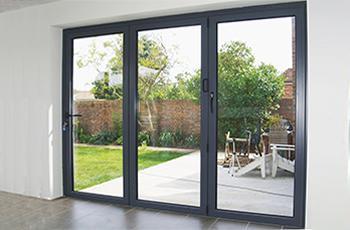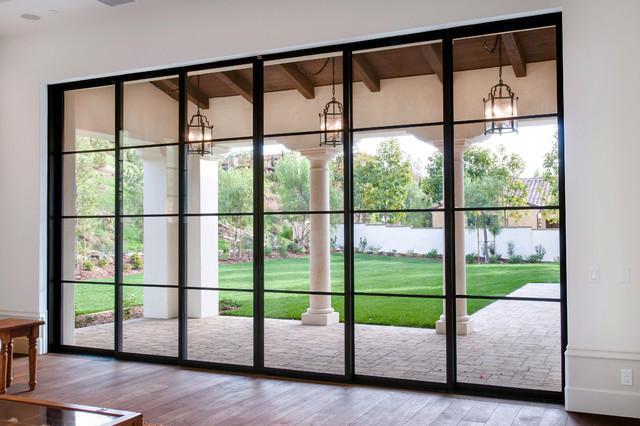The first image is the image on the left, the second image is the image on the right. Considering the images on both sides, is "A sliding glass door unit has three door-shaped sections and no door is open." valid? Answer yes or no. Yes. 